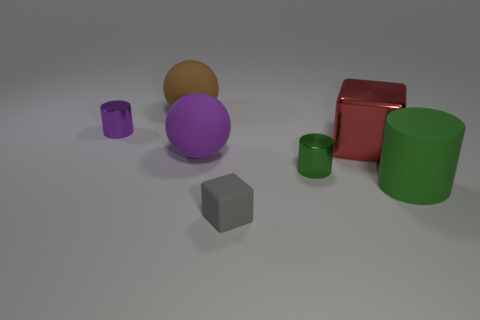The thing that is to the left of the brown ball has what shape?
Your response must be concise. Cylinder. There is a cube to the right of the small rubber thing; does it have the same color as the rubber cylinder?
Provide a short and direct response. No. There is a big sphere behind the ball in front of the small purple thing; are there any large cylinders that are to the left of it?
Provide a succinct answer. No. There is a shiny cylinder that is behind the red thing; what is its color?
Offer a terse response. Purple. Is the small green shiny object the same shape as the big brown rubber object?
Ensure brevity in your answer.  No. The matte thing that is left of the green shiny cylinder and in front of the small green cylinder is what color?
Make the answer very short. Gray. There is a block that is behind the large green matte object; is its size the same as the cube in front of the big cube?
Provide a short and direct response. No. Is the size of the green metal cylinder the same as the green rubber cylinder?
Provide a succinct answer. No. There is a small metal object right of the block that is left of the green shiny thing; what is its color?
Your answer should be very brief. Green. Are there fewer gray things behind the red metallic block than large metallic objects left of the tiny purple cylinder?
Provide a short and direct response. No. 